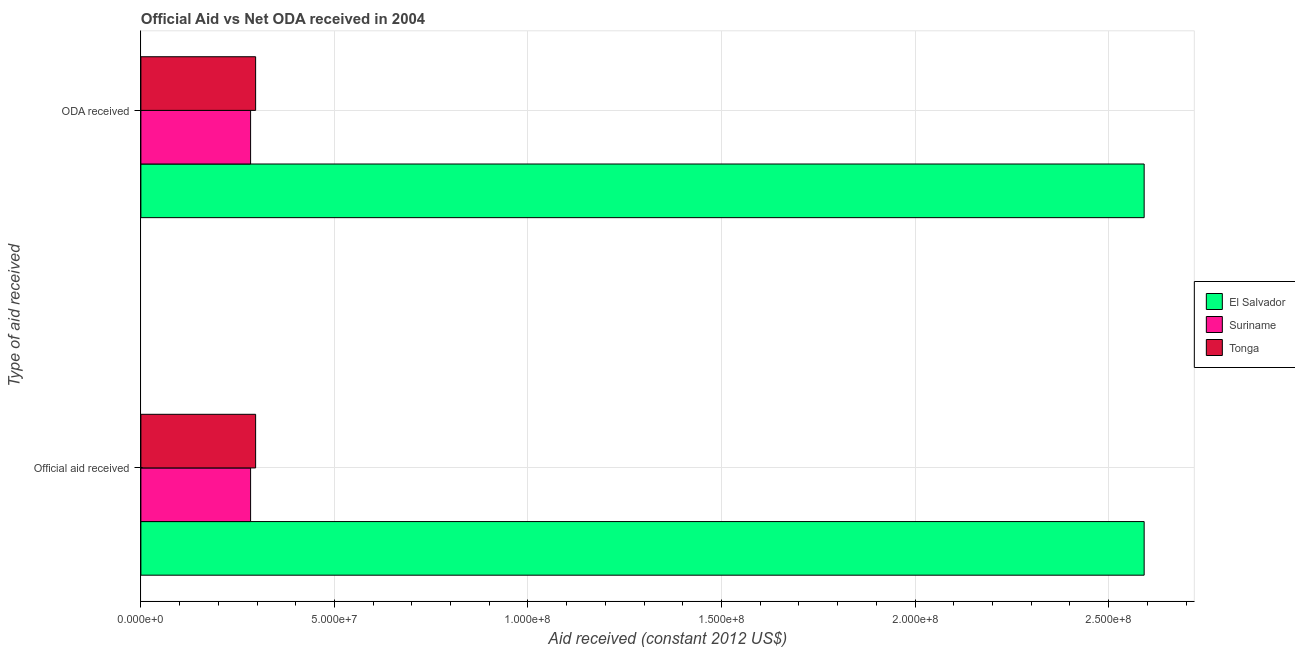How many different coloured bars are there?
Provide a short and direct response. 3. How many bars are there on the 1st tick from the top?
Offer a very short reply. 3. How many bars are there on the 1st tick from the bottom?
Provide a short and direct response. 3. What is the label of the 2nd group of bars from the top?
Your answer should be compact. Official aid received. What is the official aid received in Tonga?
Provide a succinct answer. 2.96e+07. Across all countries, what is the maximum official aid received?
Your answer should be compact. 2.59e+08. Across all countries, what is the minimum official aid received?
Provide a succinct answer. 2.83e+07. In which country was the oda received maximum?
Make the answer very short. El Salvador. In which country was the official aid received minimum?
Your response must be concise. Suriname. What is the total oda received in the graph?
Provide a succinct answer. 3.17e+08. What is the difference between the oda received in Tonga and that in El Salvador?
Keep it short and to the point. -2.30e+08. What is the difference between the oda received in El Salvador and the official aid received in Suriname?
Your response must be concise. 2.31e+08. What is the average oda received per country?
Ensure brevity in your answer.  1.06e+08. In how many countries, is the official aid received greater than 90000000 US$?
Your response must be concise. 1. What is the ratio of the official aid received in Suriname to that in Tonga?
Your answer should be very brief. 0.96. Is the official aid received in El Salvador less than that in Suriname?
Keep it short and to the point. No. In how many countries, is the oda received greater than the average oda received taken over all countries?
Your answer should be very brief. 1. What does the 1st bar from the top in Official aid received represents?
Provide a succinct answer. Tonga. What does the 2nd bar from the bottom in Official aid received represents?
Give a very brief answer. Suriname. How many bars are there?
Offer a terse response. 6. How many countries are there in the graph?
Give a very brief answer. 3. How many legend labels are there?
Provide a short and direct response. 3. What is the title of the graph?
Offer a very short reply. Official Aid vs Net ODA received in 2004 . Does "Sierra Leone" appear as one of the legend labels in the graph?
Keep it short and to the point. No. What is the label or title of the X-axis?
Your answer should be very brief. Aid received (constant 2012 US$). What is the label or title of the Y-axis?
Offer a terse response. Type of aid received. What is the Aid received (constant 2012 US$) of El Salvador in Official aid received?
Offer a terse response. 2.59e+08. What is the Aid received (constant 2012 US$) in Suriname in Official aid received?
Give a very brief answer. 2.83e+07. What is the Aid received (constant 2012 US$) in Tonga in Official aid received?
Your answer should be compact. 2.96e+07. What is the Aid received (constant 2012 US$) of El Salvador in ODA received?
Give a very brief answer. 2.59e+08. What is the Aid received (constant 2012 US$) of Suriname in ODA received?
Offer a terse response. 2.83e+07. What is the Aid received (constant 2012 US$) of Tonga in ODA received?
Make the answer very short. 2.96e+07. Across all Type of aid received, what is the maximum Aid received (constant 2012 US$) in El Salvador?
Provide a succinct answer. 2.59e+08. Across all Type of aid received, what is the maximum Aid received (constant 2012 US$) in Suriname?
Offer a terse response. 2.83e+07. Across all Type of aid received, what is the maximum Aid received (constant 2012 US$) in Tonga?
Offer a terse response. 2.96e+07. Across all Type of aid received, what is the minimum Aid received (constant 2012 US$) in El Salvador?
Make the answer very short. 2.59e+08. Across all Type of aid received, what is the minimum Aid received (constant 2012 US$) of Suriname?
Provide a short and direct response. 2.83e+07. Across all Type of aid received, what is the minimum Aid received (constant 2012 US$) in Tonga?
Make the answer very short. 2.96e+07. What is the total Aid received (constant 2012 US$) of El Salvador in the graph?
Keep it short and to the point. 5.18e+08. What is the total Aid received (constant 2012 US$) in Suriname in the graph?
Provide a short and direct response. 5.67e+07. What is the total Aid received (constant 2012 US$) in Tonga in the graph?
Ensure brevity in your answer.  5.93e+07. What is the difference between the Aid received (constant 2012 US$) of El Salvador in Official aid received and that in ODA received?
Offer a very short reply. 0. What is the difference between the Aid received (constant 2012 US$) in Suriname in Official aid received and that in ODA received?
Your response must be concise. 0. What is the difference between the Aid received (constant 2012 US$) in Tonga in Official aid received and that in ODA received?
Make the answer very short. 0. What is the difference between the Aid received (constant 2012 US$) of El Salvador in Official aid received and the Aid received (constant 2012 US$) of Suriname in ODA received?
Provide a short and direct response. 2.31e+08. What is the difference between the Aid received (constant 2012 US$) in El Salvador in Official aid received and the Aid received (constant 2012 US$) in Tonga in ODA received?
Provide a succinct answer. 2.30e+08. What is the difference between the Aid received (constant 2012 US$) of Suriname in Official aid received and the Aid received (constant 2012 US$) of Tonga in ODA received?
Your answer should be compact. -1.30e+06. What is the average Aid received (constant 2012 US$) of El Salvador per Type of aid received?
Your answer should be compact. 2.59e+08. What is the average Aid received (constant 2012 US$) in Suriname per Type of aid received?
Your response must be concise. 2.83e+07. What is the average Aid received (constant 2012 US$) of Tonga per Type of aid received?
Provide a short and direct response. 2.96e+07. What is the difference between the Aid received (constant 2012 US$) of El Salvador and Aid received (constant 2012 US$) of Suriname in Official aid received?
Your answer should be very brief. 2.31e+08. What is the difference between the Aid received (constant 2012 US$) of El Salvador and Aid received (constant 2012 US$) of Tonga in Official aid received?
Offer a very short reply. 2.30e+08. What is the difference between the Aid received (constant 2012 US$) of Suriname and Aid received (constant 2012 US$) of Tonga in Official aid received?
Provide a short and direct response. -1.30e+06. What is the difference between the Aid received (constant 2012 US$) in El Salvador and Aid received (constant 2012 US$) in Suriname in ODA received?
Offer a very short reply. 2.31e+08. What is the difference between the Aid received (constant 2012 US$) in El Salvador and Aid received (constant 2012 US$) in Tonga in ODA received?
Ensure brevity in your answer.  2.30e+08. What is the difference between the Aid received (constant 2012 US$) of Suriname and Aid received (constant 2012 US$) of Tonga in ODA received?
Your answer should be very brief. -1.30e+06. What is the ratio of the Aid received (constant 2012 US$) in El Salvador in Official aid received to that in ODA received?
Offer a very short reply. 1. What is the ratio of the Aid received (constant 2012 US$) in Suriname in Official aid received to that in ODA received?
Offer a very short reply. 1. What is the difference between the highest and the second highest Aid received (constant 2012 US$) of Suriname?
Provide a succinct answer. 0. What is the difference between the highest and the lowest Aid received (constant 2012 US$) of El Salvador?
Give a very brief answer. 0. What is the difference between the highest and the lowest Aid received (constant 2012 US$) of Tonga?
Offer a terse response. 0. 